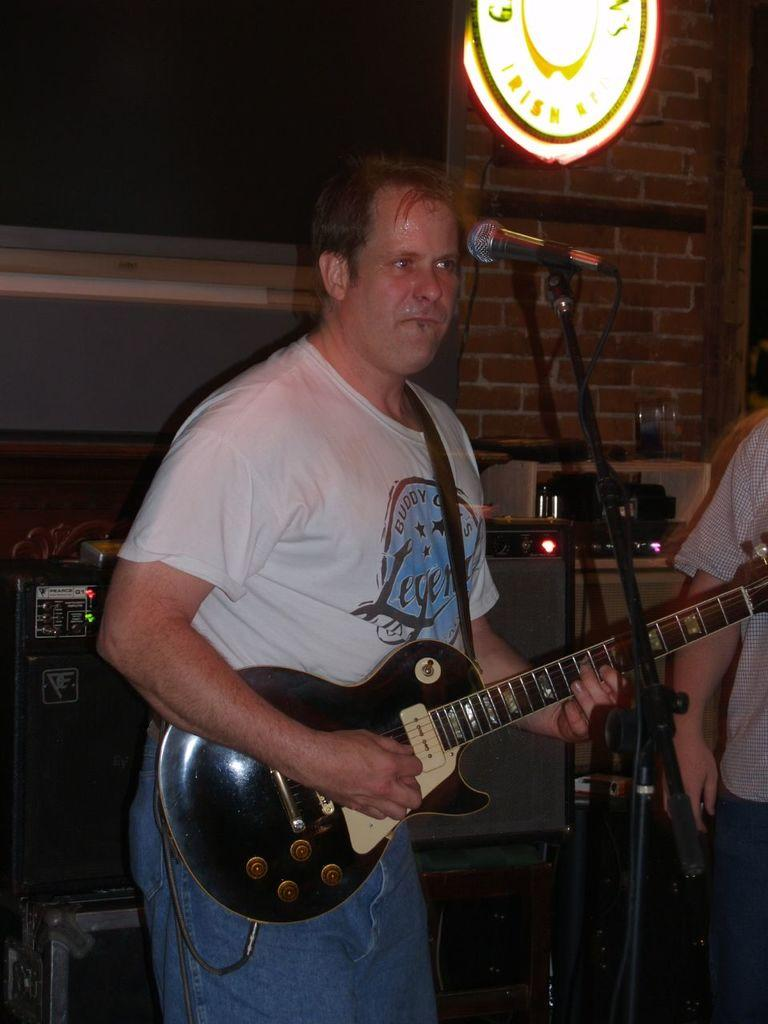What is the main subject of the image? The main subject of the image is a man. What is the man wearing? The man is wearing a white t-shirt and blue jeans. What is the man holding in the image? The man is holding a guitar. What is in front of the man that is related to music? There is a microphone and other musical instruments in front of the man. What time of day is it in the image, based on the sense of morning? The time of day cannot be determined from the image, and there is no mention of a sense of morning in the provided facts. 